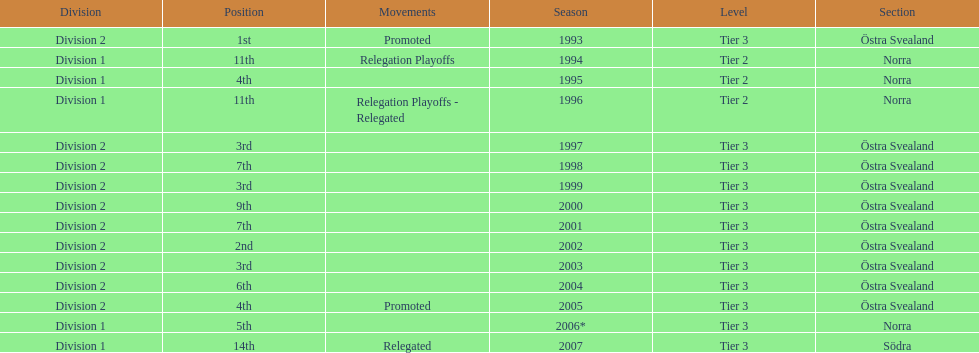What are the number of times norra was listed as the section? 4. 